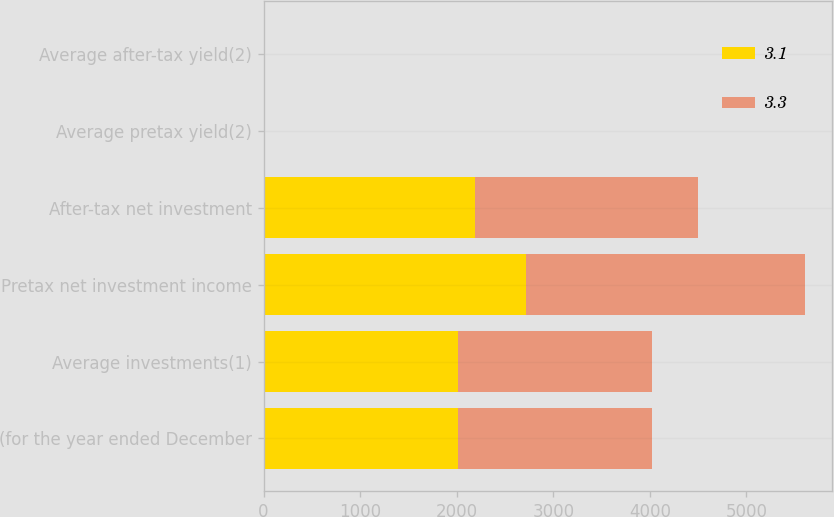<chart> <loc_0><loc_0><loc_500><loc_500><stacked_bar_chart><ecel><fcel>(for the year ended December<fcel>Average investments(1)<fcel>Pretax net investment income<fcel>After-tax net investment<fcel>Average pretax yield(2)<fcel>Average after-tax yield(2)<nl><fcel>3.1<fcel>2013<fcel>2012.5<fcel>2716<fcel>2186<fcel>3.8<fcel>3.1<nl><fcel>3.3<fcel>2012<fcel>2012.5<fcel>2889<fcel>2316<fcel>4.1<fcel>3.3<nl></chart> 